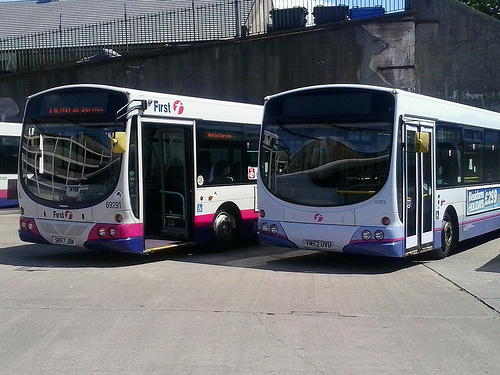Can you tell me what the numbers on the buses indicate? The numbers on the buses typically indicate the service route or number that the bus is operating on. They help passengers identify which bus to take for their desired destination. 